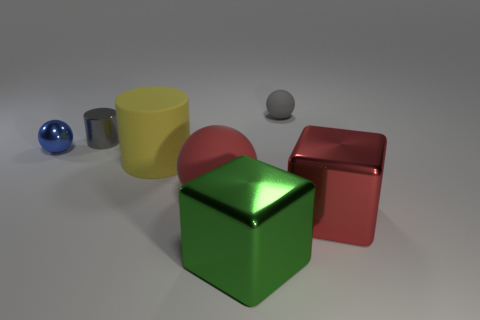Add 2 large matte things. How many objects exist? 9 Subtract all cylinders. How many objects are left? 5 Subtract 0 purple cubes. How many objects are left? 7 Subtract all large metallic things. Subtract all gray spheres. How many objects are left? 4 Add 6 large red metallic things. How many large red metallic things are left? 7 Add 2 large metal things. How many large metal things exist? 4 